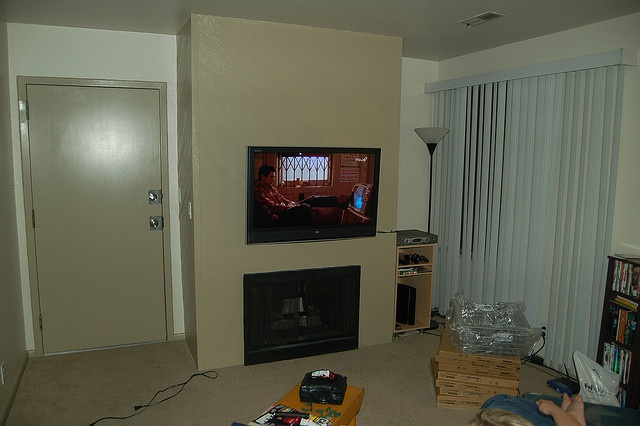Describe the objects in this image and their specific colors. I can see tv in darkgreen, black, maroon, gray, and darkgray tones, tv in darkgreen, black, maroon, gray, and darkgray tones, people in darkgreen, gray, and black tones, people in darkgreen, black, maroon, and brown tones, and book in darkgreen, black, gray, and teal tones in this image. 